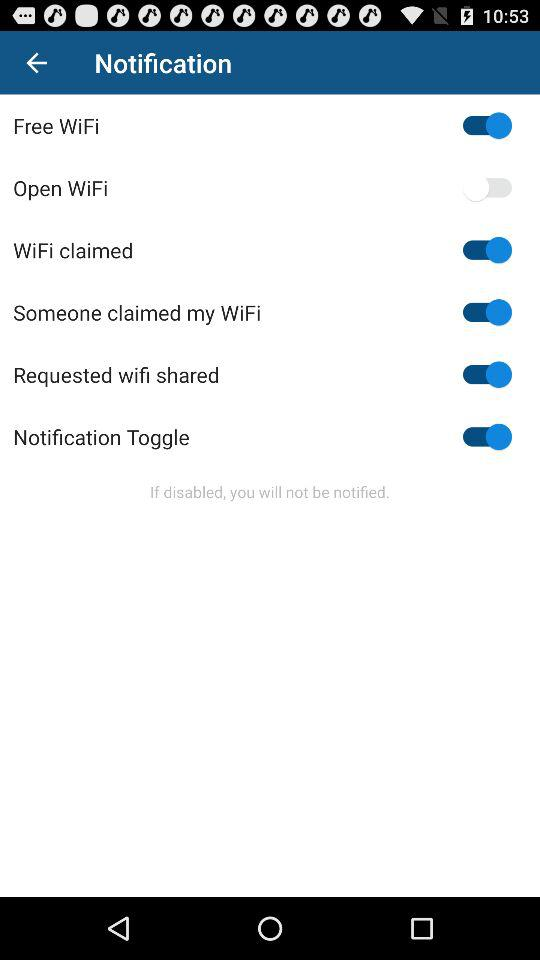What is the status of "Free WiFi"? The status is on. 